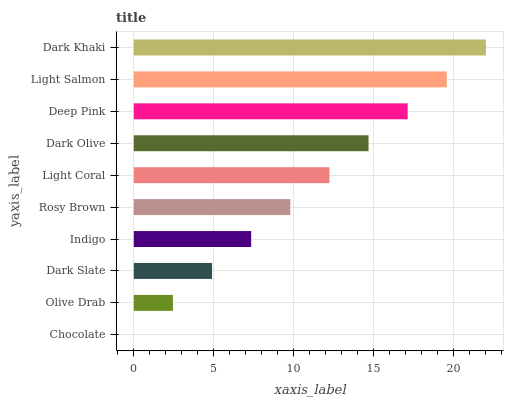Is Chocolate the minimum?
Answer yes or no. Yes. Is Dark Khaki the maximum?
Answer yes or no. Yes. Is Olive Drab the minimum?
Answer yes or no. No. Is Olive Drab the maximum?
Answer yes or no. No. Is Olive Drab greater than Chocolate?
Answer yes or no. Yes. Is Chocolate less than Olive Drab?
Answer yes or no. Yes. Is Chocolate greater than Olive Drab?
Answer yes or no. No. Is Olive Drab less than Chocolate?
Answer yes or no. No. Is Light Coral the high median?
Answer yes or no. Yes. Is Rosy Brown the low median?
Answer yes or no. Yes. Is Light Salmon the high median?
Answer yes or no. No. Is Deep Pink the low median?
Answer yes or no. No. 